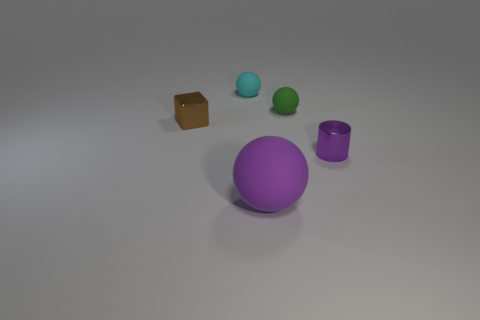Is there any other thing that has the same size as the purple rubber thing?
Give a very brief answer. No. Do the metal thing on the right side of the small cyan rubber ball and the large rubber ball have the same color?
Provide a short and direct response. Yes. The other object that is the same material as the brown thing is what color?
Provide a short and direct response. Purple. Is the size of the green thing the same as the brown metallic cube?
Ensure brevity in your answer.  Yes. What is the brown block made of?
Provide a succinct answer. Metal. What is the material of the purple thing that is the same size as the green thing?
Offer a very short reply. Metal. Is there a gray metal thing of the same size as the cyan rubber thing?
Provide a succinct answer. No. Is the number of shiny cylinders that are to the left of the small cyan matte thing the same as the number of green rubber objects in front of the small green object?
Make the answer very short. Yes. Are there more cylinders than large brown rubber things?
Your response must be concise. Yes. What number of shiny things are green balls or small cyan things?
Give a very brief answer. 0. 